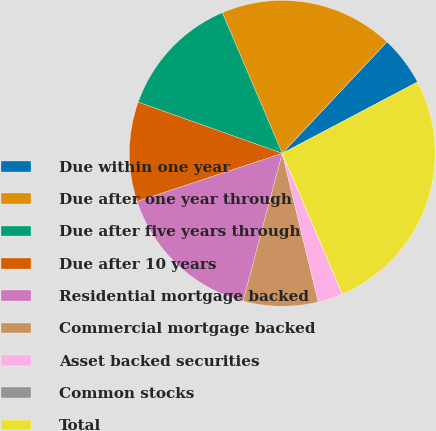Convert chart. <chart><loc_0><loc_0><loc_500><loc_500><pie_chart><fcel>Due within one year<fcel>Due after one year through<fcel>Due after five years through<fcel>Due after 10 years<fcel>Residential mortgage backed<fcel>Commercial mortgage backed<fcel>Asset backed securities<fcel>Common stocks<fcel>Total<nl><fcel>5.27%<fcel>18.42%<fcel>13.16%<fcel>10.53%<fcel>15.79%<fcel>7.9%<fcel>2.64%<fcel>0.01%<fcel>26.31%<nl></chart> 